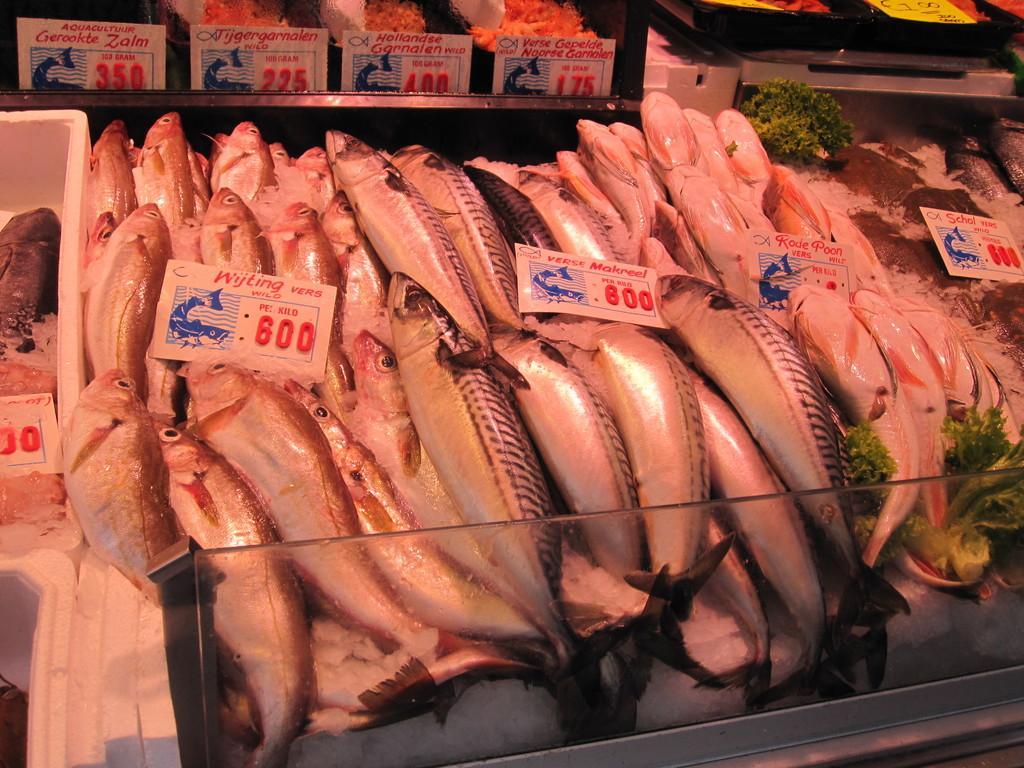Could you give a brief overview of what you see in this image? In this picture we can see fishes, broccoli, price tags, some objects and these all are on platforms. 